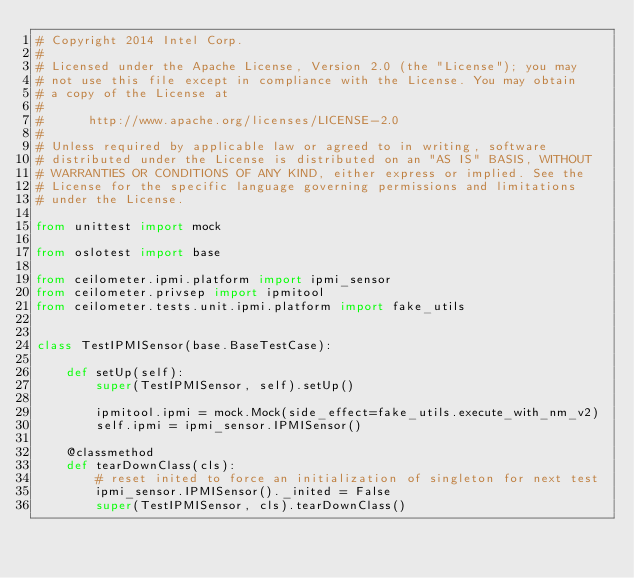<code> <loc_0><loc_0><loc_500><loc_500><_Python_># Copyright 2014 Intel Corp.
#
# Licensed under the Apache License, Version 2.0 (the "License"); you may
# not use this file except in compliance with the License. You may obtain
# a copy of the License at
#
#      http://www.apache.org/licenses/LICENSE-2.0
#
# Unless required by applicable law or agreed to in writing, software
# distributed under the License is distributed on an "AS IS" BASIS, WITHOUT
# WARRANTIES OR CONDITIONS OF ANY KIND, either express or implied. See the
# License for the specific language governing permissions and limitations
# under the License.

from unittest import mock

from oslotest import base

from ceilometer.ipmi.platform import ipmi_sensor
from ceilometer.privsep import ipmitool
from ceilometer.tests.unit.ipmi.platform import fake_utils


class TestIPMISensor(base.BaseTestCase):

    def setUp(self):
        super(TestIPMISensor, self).setUp()

        ipmitool.ipmi = mock.Mock(side_effect=fake_utils.execute_with_nm_v2)
        self.ipmi = ipmi_sensor.IPMISensor()

    @classmethod
    def tearDownClass(cls):
        # reset inited to force an initialization of singleton for next test
        ipmi_sensor.IPMISensor()._inited = False
        super(TestIPMISensor, cls).tearDownClass()
</code> 